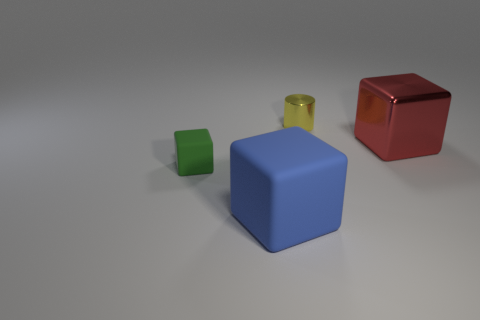Do the large cube behind the large blue rubber block and the big cube that is in front of the green rubber thing have the same material?
Offer a very short reply. No. How many big purple spheres are there?
Offer a terse response. 0. What number of red metal objects have the same shape as the green rubber thing?
Keep it short and to the point. 1. Does the yellow object have the same shape as the green rubber thing?
Provide a succinct answer. No. The shiny cube is what size?
Give a very brief answer. Large. How many other metallic objects have the same size as the red object?
Your answer should be very brief. 0. Do the metallic object right of the metallic cylinder and the rubber thing that is in front of the green rubber object have the same size?
Your answer should be compact. Yes. What is the shape of the thing that is to the right of the yellow metal cylinder?
Provide a succinct answer. Cube. What material is the small object that is on the left side of the big block that is on the left side of the large red metallic object made of?
Keep it short and to the point. Rubber. There is a green object; does it have the same size as the metallic thing that is in front of the yellow thing?
Make the answer very short. No. 